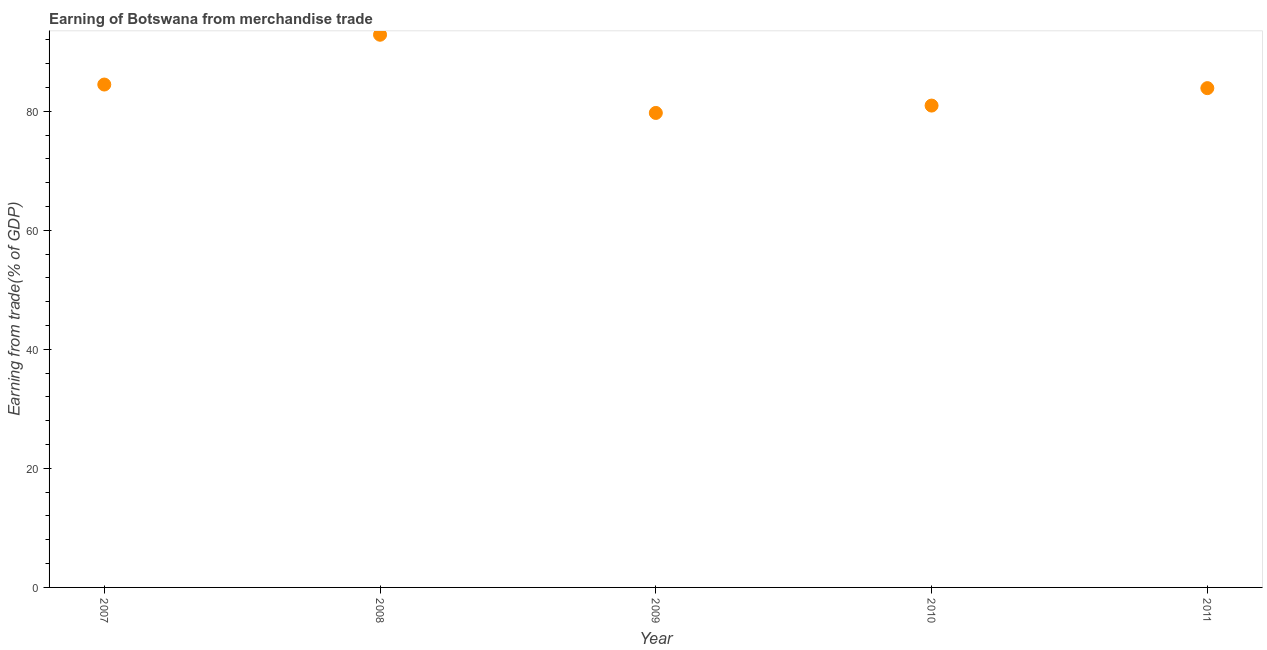What is the earning from merchandise trade in 2007?
Your answer should be compact. 84.48. Across all years, what is the maximum earning from merchandise trade?
Your answer should be very brief. 92.85. Across all years, what is the minimum earning from merchandise trade?
Your answer should be compact. 79.71. In which year was the earning from merchandise trade maximum?
Make the answer very short. 2008. In which year was the earning from merchandise trade minimum?
Provide a short and direct response. 2009. What is the sum of the earning from merchandise trade?
Provide a short and direct response. 421.85. What is the difference between the earning from merchandise trade in 2007 and 2010?
Your answer should be very brief. 3.54. What is the average earning from merchandise trade per year?
Give a very brief answer. 84.37. What is the median earning from merchandise trade?
Offer a very short reply. 83.87. In how many years, is the earning from merchandise trade greater than 32 %?
Make the answer very short. 5. Do a majority of the years between 2007 and 2011 (inclusive) have earning from merchandise trade greater than 20 %?
Provide a short and direct response. Yes. What is the ratio of the earning from merchandise trade in 2010 to that in 2011?
Your answer should be compact. 0.97. Is the earning from merchandise trade in 2007 less than that in 2008?
Provide a succinct answer. Yes. Is the difference between the earning from merchandise trade in 2008 and 2011 greater than the difference between any two years?
Keep it short and to the point. No. What is the difference between the highest and the second highest earning from merchandise trade?
Offer a terse response. 8.37. Is the sum of the earning from merchandise trade in 2007 and 2011 greater than the maximum earning from merchandise trade across all years?
Your answer should be compact. Yes. What is the difference between the highest and the lowest earning from merchandise trade?
Keep it short and to the point. 13.14. In how many years, is the earning from merchandise trade greater than the average earning from merchandise trade taken over all years?
Ensure brevity in your answer.  2. Are the values on the major ticks of Y-axis written in scientific E-notation?
Offer a terse response. No. Does the graph contain any zero values?
Provide a short and direct response. No. What is the title of the graph?
Provide a short and direct response. Earning of Botswana from merchandise trade. What is the label or title of the Y-axis?
Make the answer very short. Earning from trade(% of GDP). What is the Earning from trade(% of GDP) in 2007?
Keep it short and to the point. 84.48. What is the Earning from trade(% of GDP) in 2008?
Keep it short and to the point. 92.85. What is the Earning from trade(% of GDP) in 2009?
Your answer should be compact. 79.71. What is the Earning from trade(% of GDP) in 2010?
Your response must be concise. 80.94. What is the Earning from trade(% of GDP) in 2011?
Your answer should be very brief. 83.87. What is the difference between the Earning from trade(% of GDP) in 2007 and 2008?
Your answer should be very brief. -8.37. What is the difference between the Earning from trade(% of GDP) in 2007 and 2009?
Provide a succinct answer. 4.77. What is the difference between the Earning from trade(% of GDP) in 2007 and 2010?
Ensure brevity in your answer.  3.54. What is the difference between the Earning from trade(% of GDP) in 2007 and 2011?
Offer a very short reply. 0.61. What is the difference between the Earning from trade(% of GDP) in 2008 and 2009?
Provide a succinct answer. 13.14. What is the difference between the Earning from trade(% of GDP) in 2008 and 2010?
Ensure brevity in your answer.  11.9. What is the difference between the Earning from trade(% of GDP) in 2008 and 2011?
Offer a very short reply. 8.97. What is the difference between the Earning from trade(% of GDP) in 2009 and 2010?
Ensure brevity in your answer.  -1.24. What is the difference between the Earning from trade(% of GDP) in 2009 and 2011?
Make the answer very short. -4.17. What is the difference between the Earning from trade(% of GDP) in 2010 and 2011?
Provide a short and direct response. -2.93. What is the ratio of the Earning from trade(% of GDP) in 2007 to that in 2008?
Offer a terse response. 0.91. What is the ratio of the Earning from trade(% of GDP) in 2007 to that in 2009?
Make the answer very short. 1.06. What is the ratio of the Earning from trade(% of GDP) in 2007 to that in 2010?
Your answer should be very brief. 1.04. What is the ratio of the Earning from trade(% of GDP) in 2007 to that in 2011?
Provide a succinct answer. 1.01. What is the ratio of the Earning from trade(% of GDP) in 2008 to that in 2009?
Make the answer very short. 1.17. What is the ratio of the Earning from trade(% of GDP) in 2008 to that in 2010?
Provide a succinct answer. 1.15. What is the ratio of the Earning from trade(% of GDP) in 2008 to that in 2011?
Your response must be concise. 1.11. What is the ratio of the Earning from trade(% of GDP) in 2009 to that in 2010?
Offer a very short reply. 0.98. 